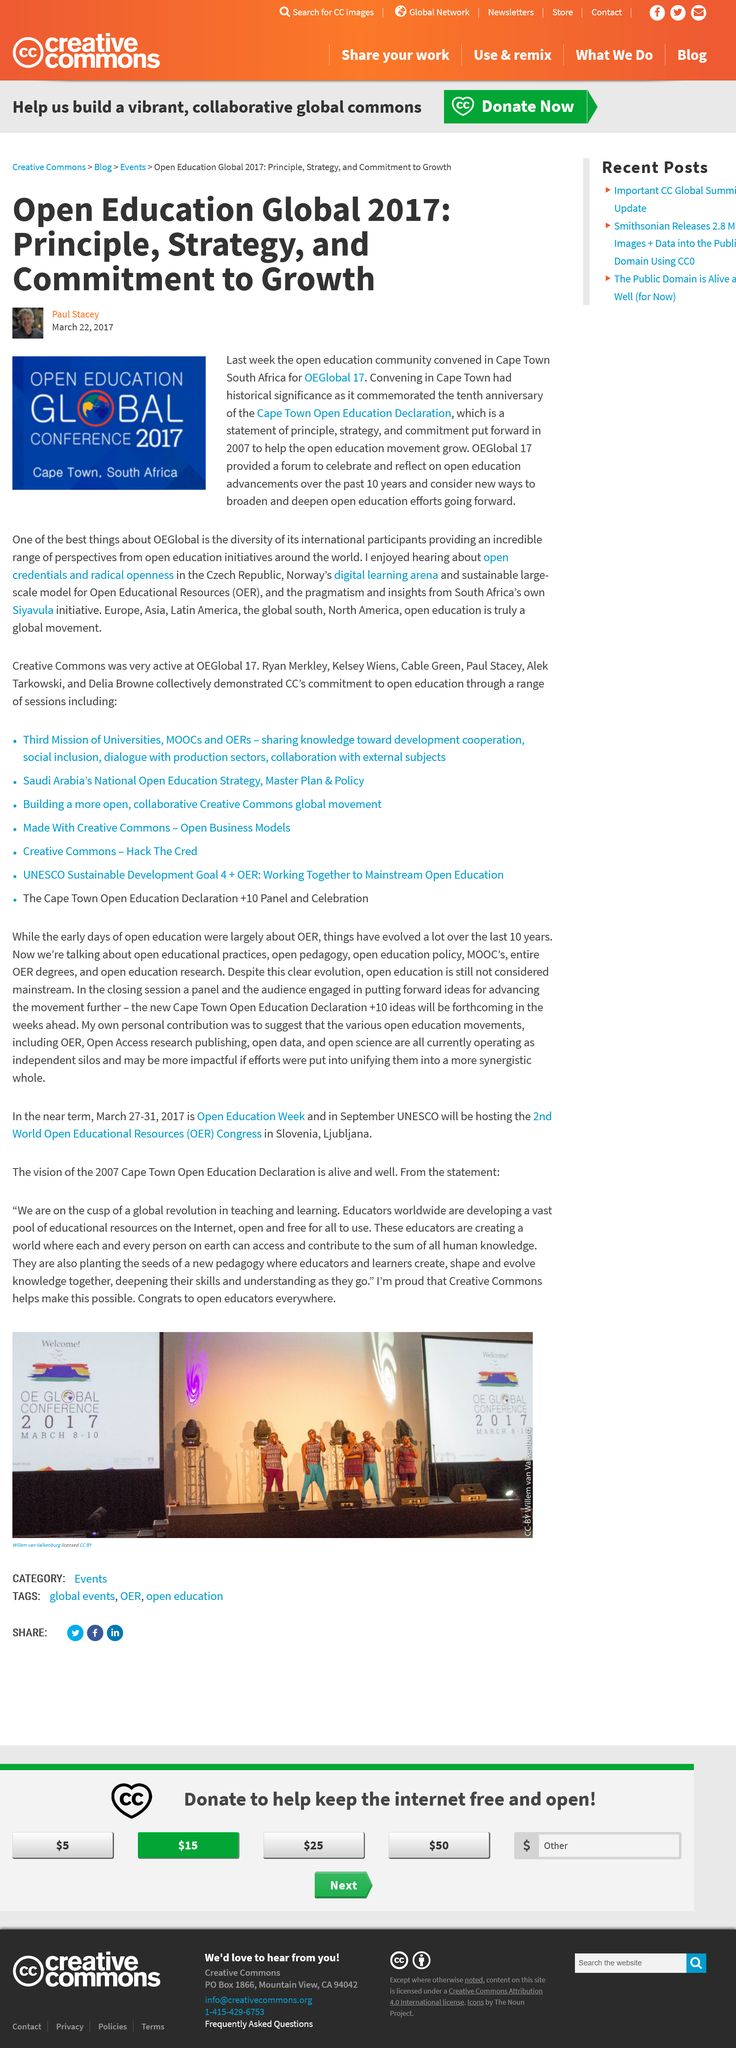List a handful of essential elements in this visual. The conference being held in Cape Town was significant in history as it commemorated the tenth anniversary of the Cape Town Open Education Declaration, a significant milestone in the advancement of open education. The author of the article is Paul Stacey. The open education community gathered in Cape Town, South Africa in 2017. 